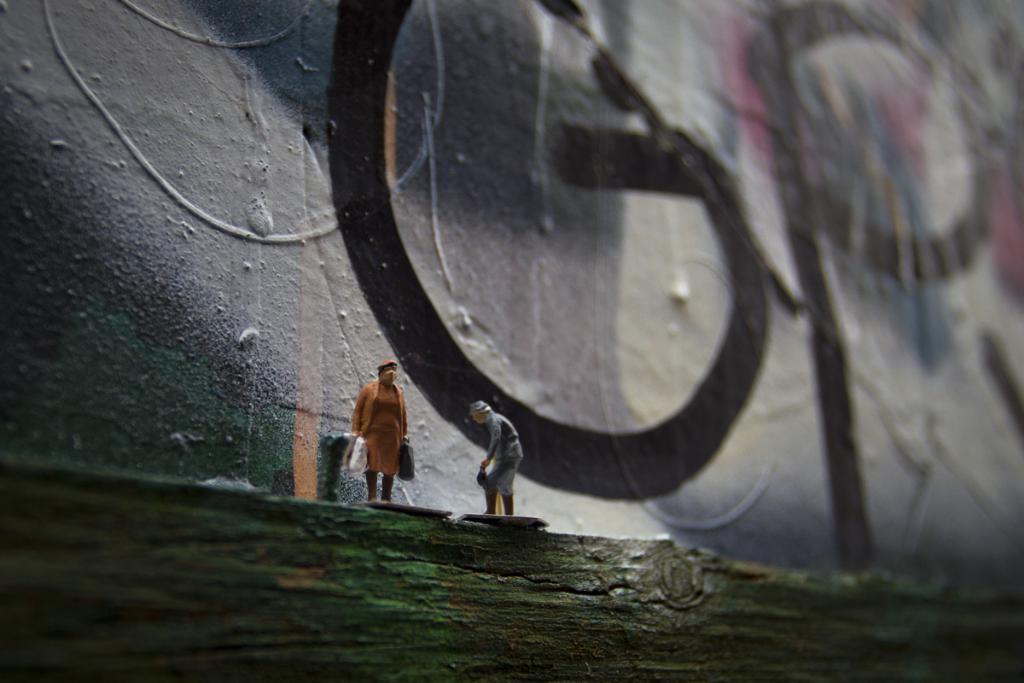In one or two sentences, can you explain what this image depicts? In this picture we can see miniatures of people on the wooden object. In the background of the image it is blurry and we can see wall. 